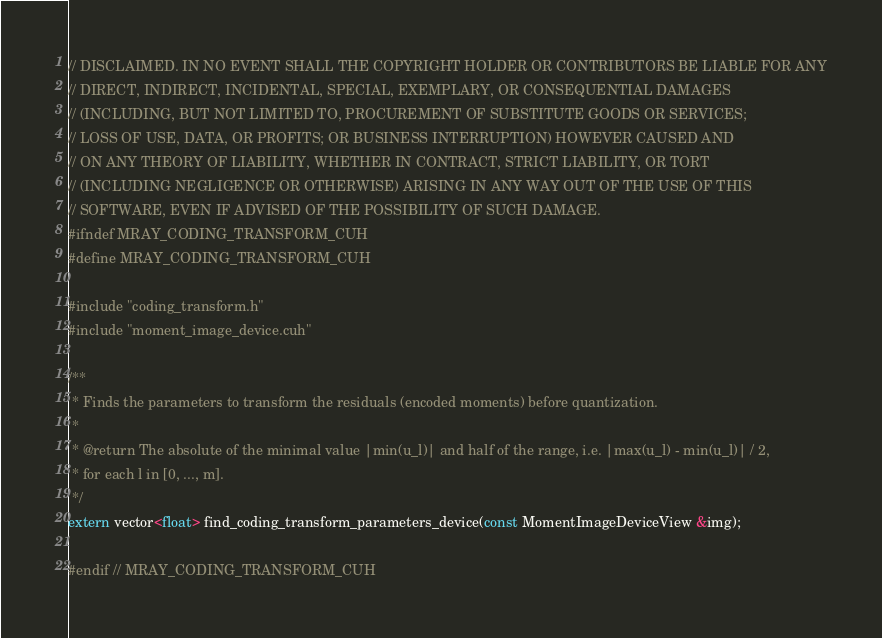<code> <loc_0><loc_0><loc_500><loc_500><_Cuda_>// DISCLAIMED. IN NO EVENT SHALL THE COPYRIGHT HOLDER OR CONTRIBUTORS BE LIABLE FOR ANY
// DIRECT, INDIRECT, INCIDENTAL, SPECIAL, EXEMPLARY, OR CONSEQUENTIAL DAMAGES
// (INCLUDING, BUT NOT LIMITED TO, PROCUREMENT OF SUBSTITUTE GOODS OR SERVICES;
// LOSS OF USE, DATA, OR PROFITS; OR BUSINESS INTERRUPTION) HOWEVER CAUSED AND
// ON ANY THEORY OF LIABILITY, WHETHER IN CONTRACT, STRICT LIABILITY, OR TORT
// (INCLUDING NEGLIGENCE OR OTHERWISE) ARISING IN ANY WAY OUT OF THE USE OF THIS
// SOFTWARE, EVEN IF ADVISED OF THE POSSIBILITY OF SUCH DAMAGE.
#ifndef MRAY_CODING_TRANSFORM_CUH
#define MRAY_CODING_TRANSFORM_CUH

#include "coding_transform.h"
#include "moment_image_device.cuh"

/**
 * Finds the parameters to transform the residuals (encoded moments) before quantization.
 *
 * @return The absolute of the minimal value |min(u_l)| and half of the range, i.e. |max(u_l) - min(u_l)| / 2,
 * for each l in [0, ..., m].
 */
extern vector<float> find_coding_transform_parameters_device(const MomentImageDeviceView &img);

#endif // MRAY_CODING_TRANSFORM_CUH
</code> 